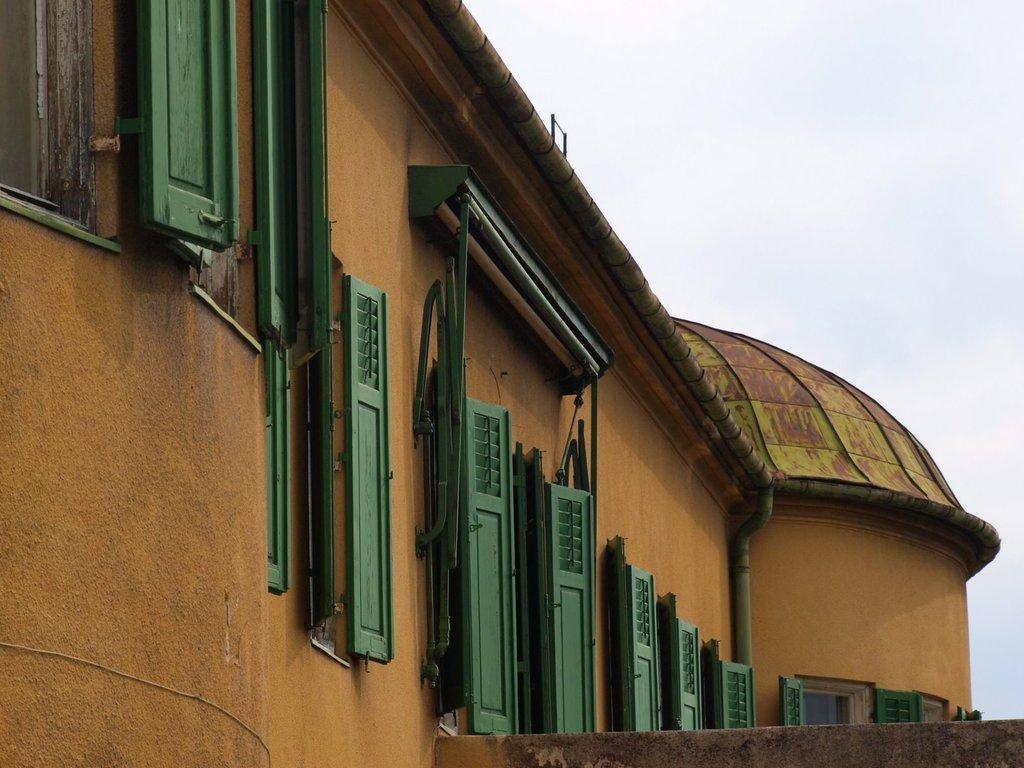What type of structure is present in the image? There is a house in the image. What feature of the house can be seen in the image? There are doors visible in the image. What songs are being sung by the house in the image? The house does not sing songs in the image; it is an inanimate object. 